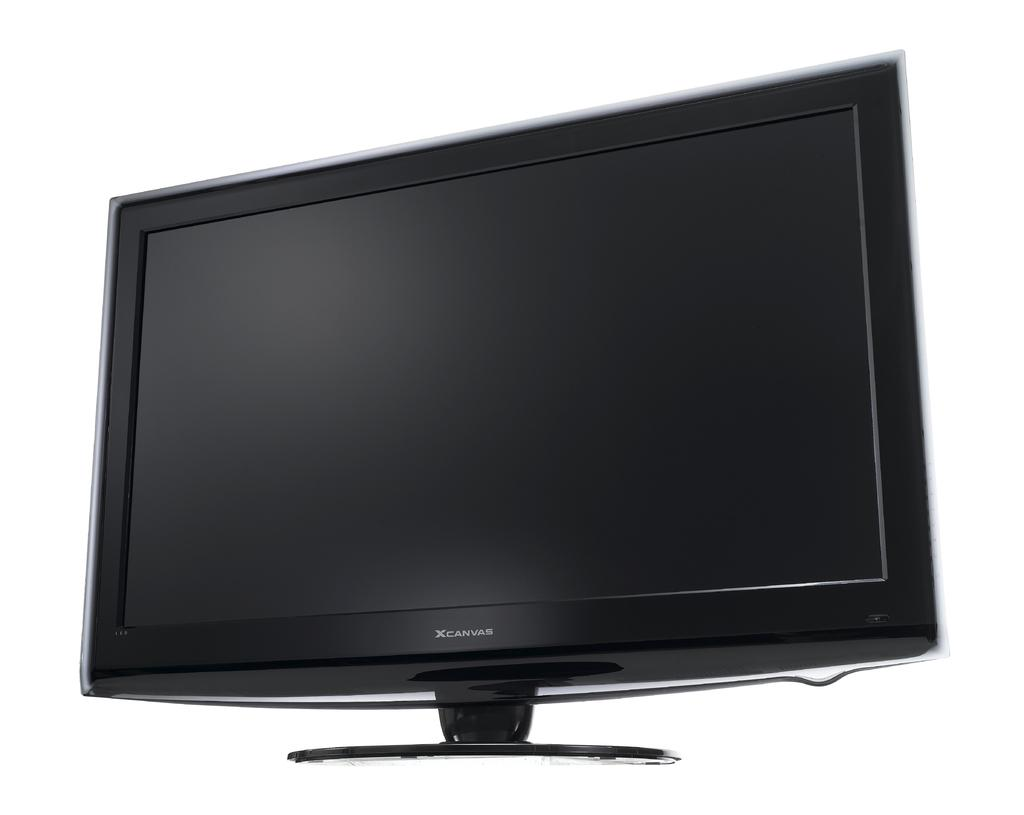What is the main object in the image? There is a television screen in the image. Can you describe the television screen in the image? The television screen is the main object in the image, and it appears to be turned on or displaying an image. What type of cactus can be seen growing on the television screen in the image? There is no cactus present on the television screen in the image; it is a flat screen displaying an image or video. 